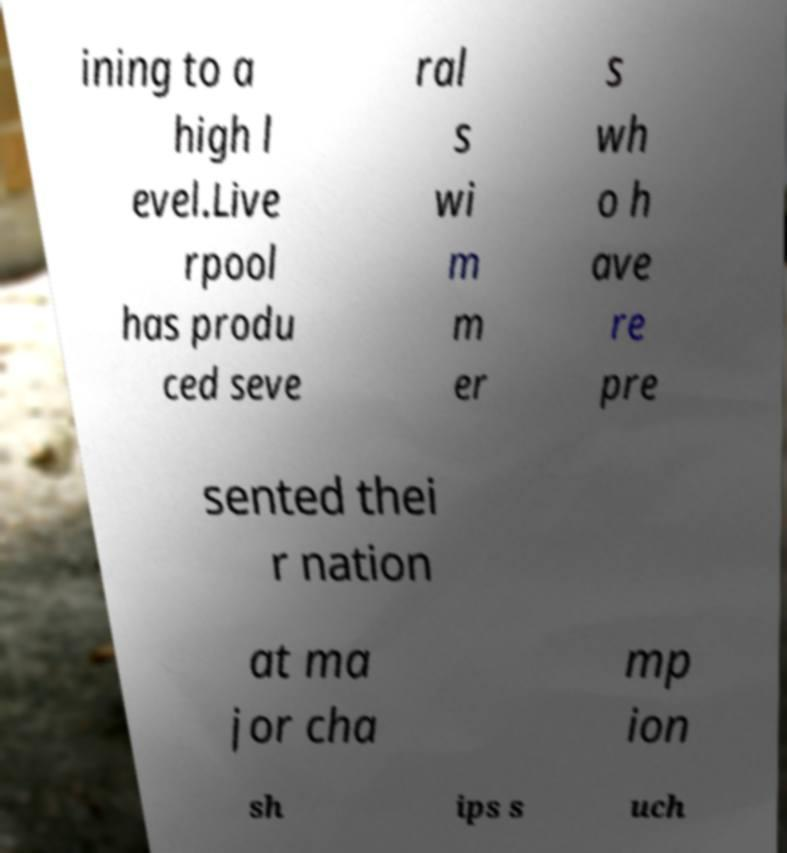Can you accurately transcribe the text from the provided image for me? ining to a high l evel.Live rpool has produ ced seve ral s wi m m er s wh o h ave re pre sented thei r nation at ma jor cha mp ion sh ips s uch 